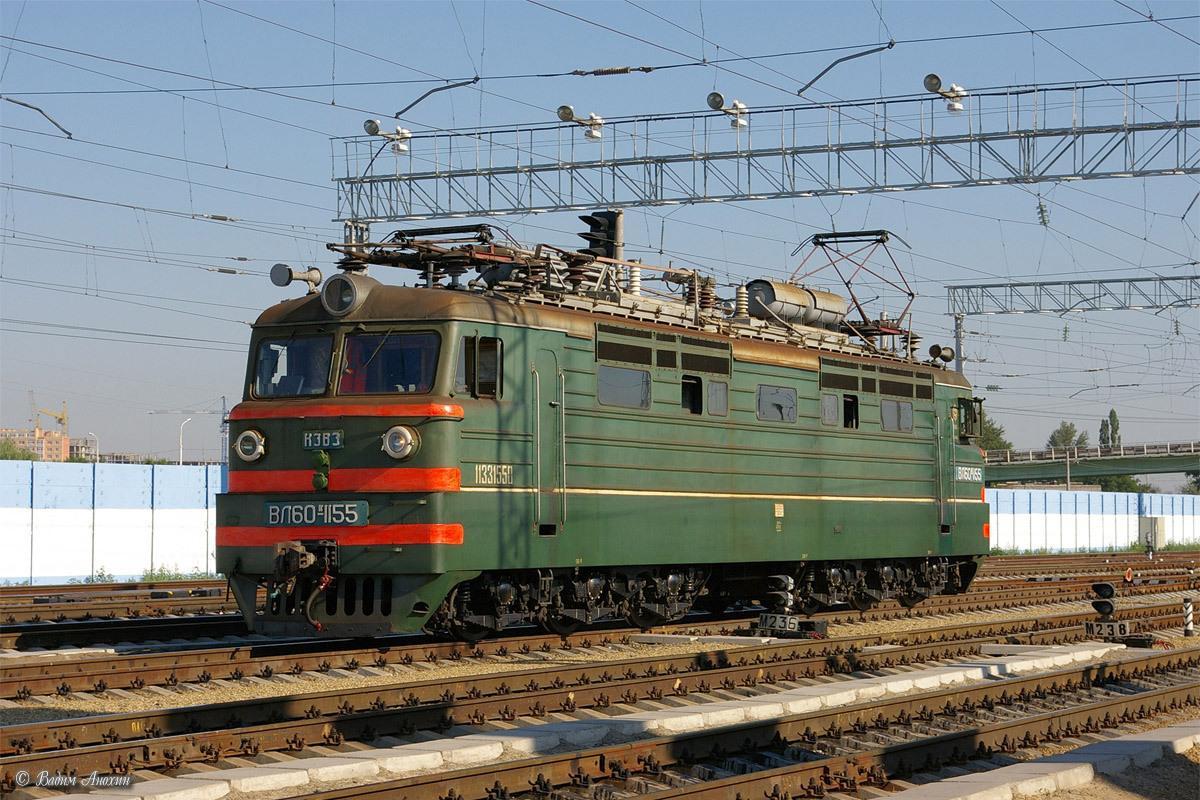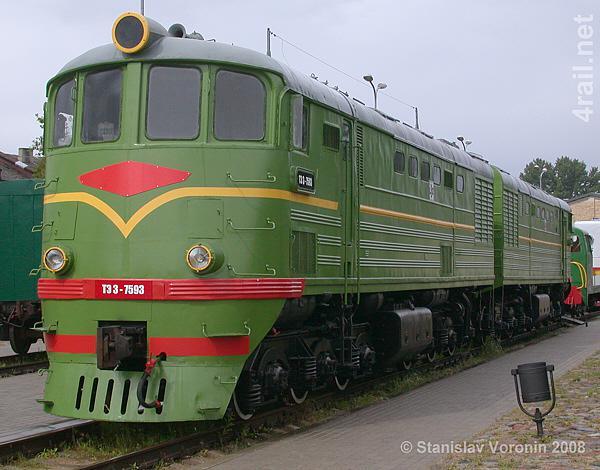The first image is the image on the left, the second image is the image on the right. Considering the images on both sides, is "All trains are angled forward in the same direction." valid? Answer yes or no. Yes. The first image is the image on the left, the second image is the image on the right. Given the left and right images, does the statement "There are two red trains sitting on train tracks." hold true? Answer yes or no. No. 